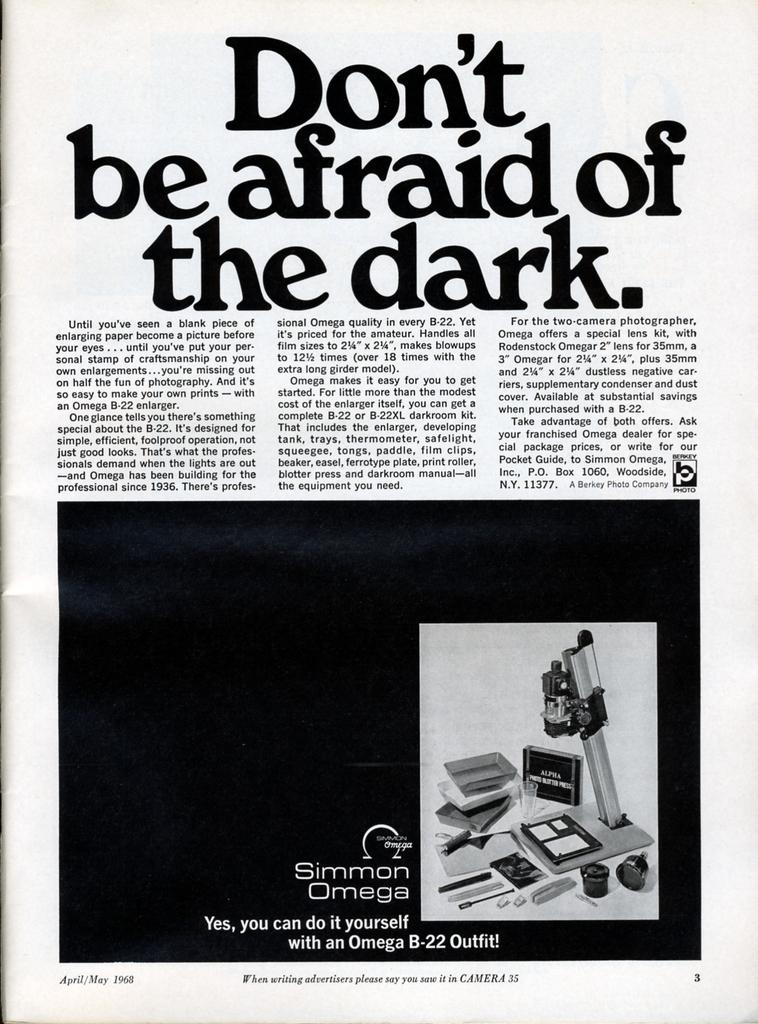<image>
Describe the image concisely. The passage is titled Don't be afraid of the dark. 